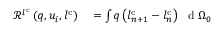<formula> <loc_0><loc_0><loc_500><loc_500>\begin{array} { r l } { \ m a t h s c r { R } ^ { l ^ { c } } \left ( q , u _ { i } , l ^ { c } \right ) } & = \int q \left ( l _ { n + 1 } ^ { c } - l _ { n } ^ { c } \right ) \ d { \Omega _ { 0 } } } \end{array}</formula> 